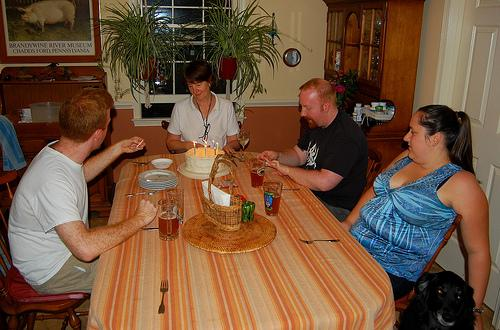Identify two objects hanging from the ceiling next to the window. Two bushy leaved plants are hanging from the ceiling next to the window. Mention an object located near the woman in blue. A black dog is sitting on the floor near the lady in blue. How many people can be seen sitting around the table? There are at least six people sitting around the table. In a single sentence, describe the table setting seen in the image. The table has an orange striped tablecloth, a brown wicker placemat with a napkin holder, stainless steel utensils, glasses of red juice, and plates stacked on it. What kind of frame surrounds the picture of the pig? The picture of the pig is in a wood frame. Describe the appearance of the red-haired man at the table. The red-haired man has short hair, wears a white t-shirt and has a beard. What is the primary emotion portrayed in the image? The primary emotion portrayed is happiness. Describe the appearance and posture of the woman with the white shirt and eyeglasses. The woman is middle-aged, wearing a white polo shirt, with her reading glasses on a lanyard around her neck, and appears to be leaning back in a chair. What is the design of the tablecloth on the table? The tablecloth is orange with stripes. What kind of celebration is taking place in the image? A middle-aged woman's birthday party is taking place. 